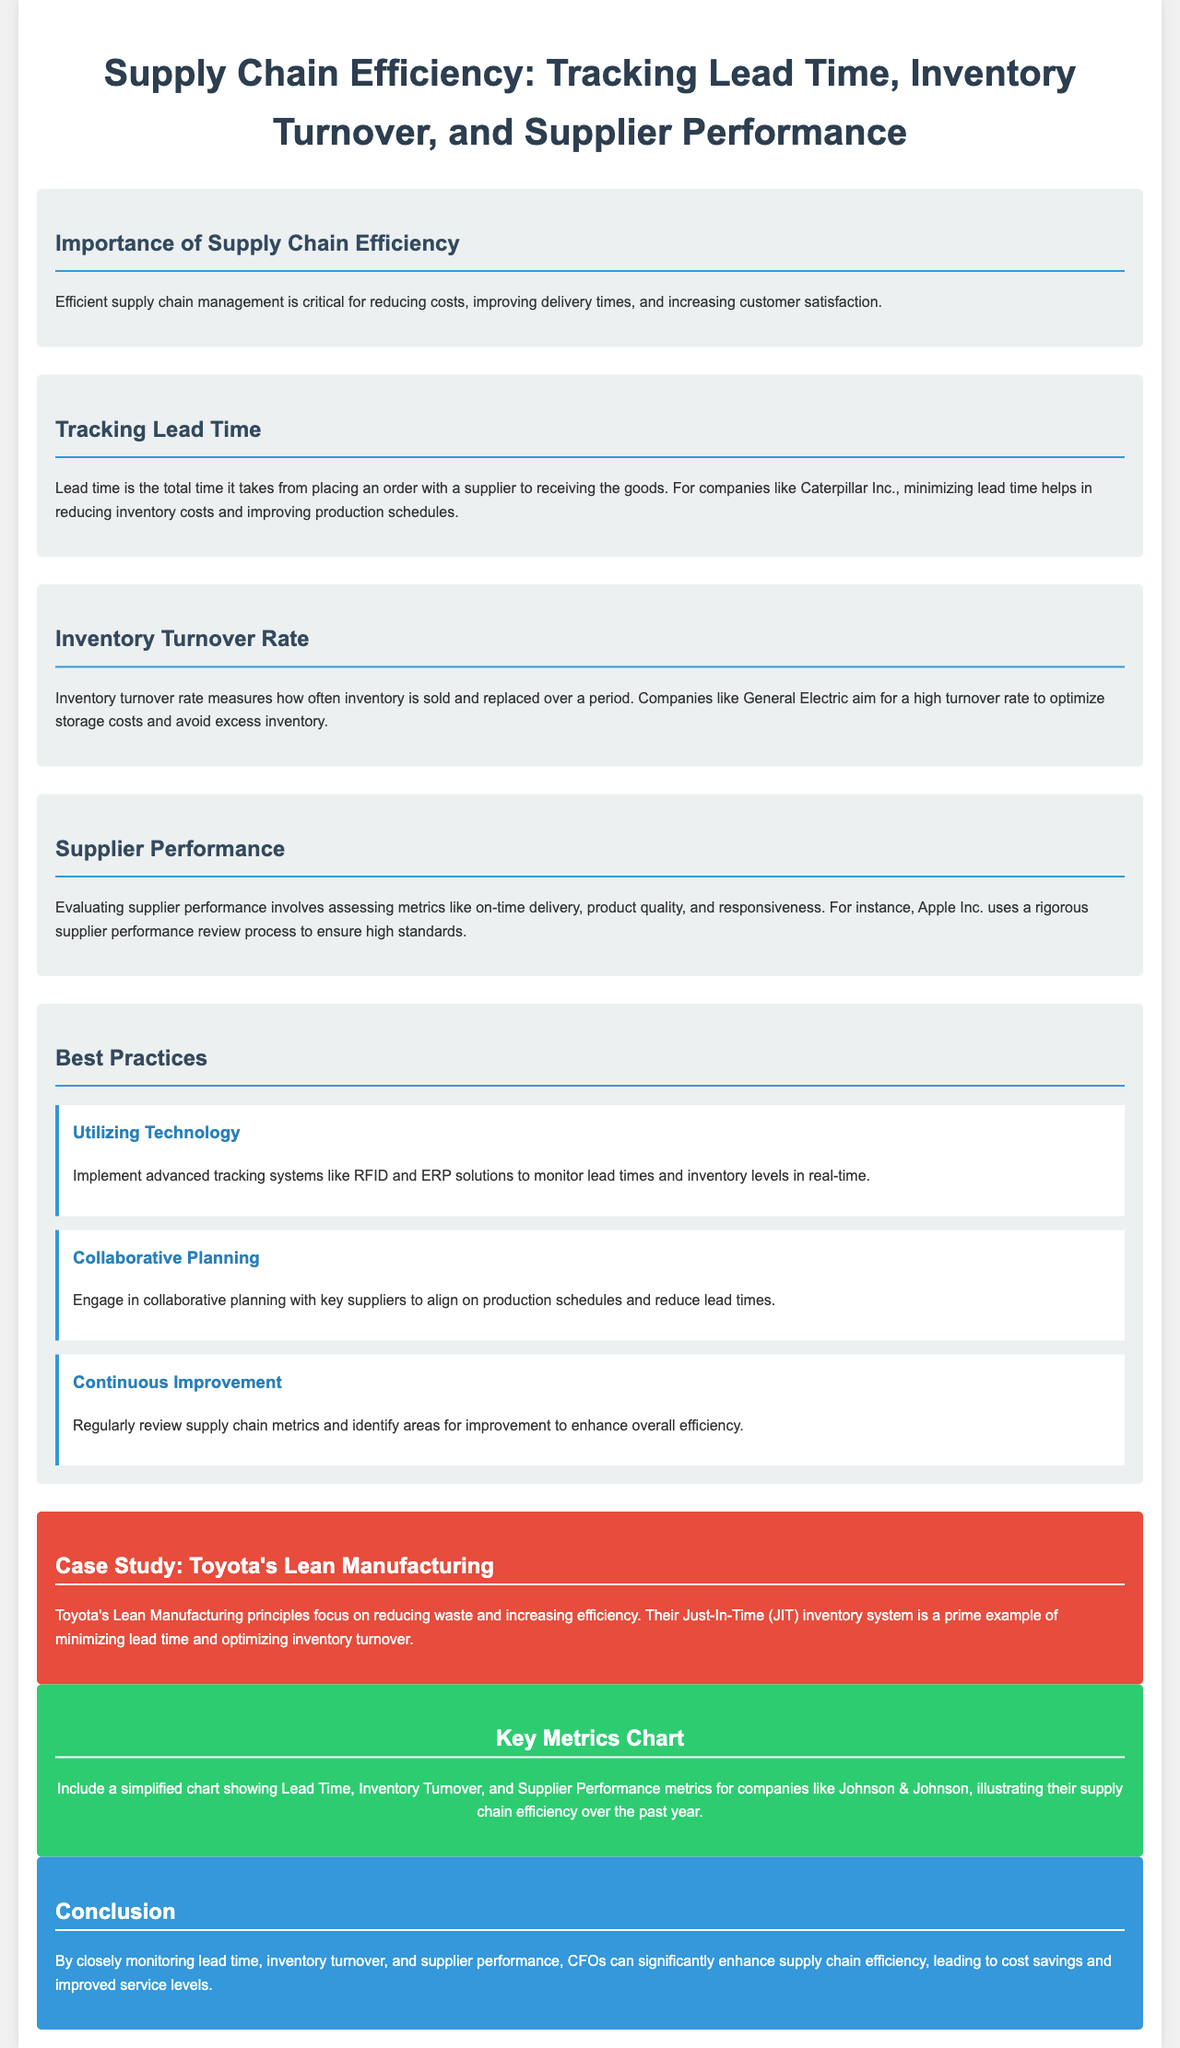what is the focus of the infographic? The infographic centers on supply chain efficiency, specifically tracking lead time, inventory turnover, and supplier performance.
Answer: supply chain efficiency what company is mentioned in relation to minimizing lead time? The document references Caterpillar Inc. in the context of minimizing lead time.
Answer: Caterpillar Inc what is the goal of companies like General Electric regarding inventory turnover? General Electric aims for a high turnover rate to optimize storage costs and avoid excess inventory.
Answer: high turnover rate which company's supplier performance review process is highlighted in the infographic? The infographic highlights Apple Inc.'s rigorous supplier performance review process.
Answer: Apple Inc what inventory system is Toyota known for? Toyota is recognized for their Just-In-Time (JIT) inventory system, which reduces lead time.
Answer: Just-In-Time (JIT) what is a recommended technology for monitoring lead times and inventory levels? Advanced tracking systems like RFID are recommended for monitoring lead times and inventory levels.
Answer: RFID what principle does Toyota's Lean Manufacturing focus on? Toyota's Lean Manufacturing principles focus on reducing waste and increasing efficiency.
Answer: reducing waste how does collaborative planning benefit supply chain efficiency? Collaborative planning helps align on production schedules and reduce lead times.
Answer: reduces lead times 